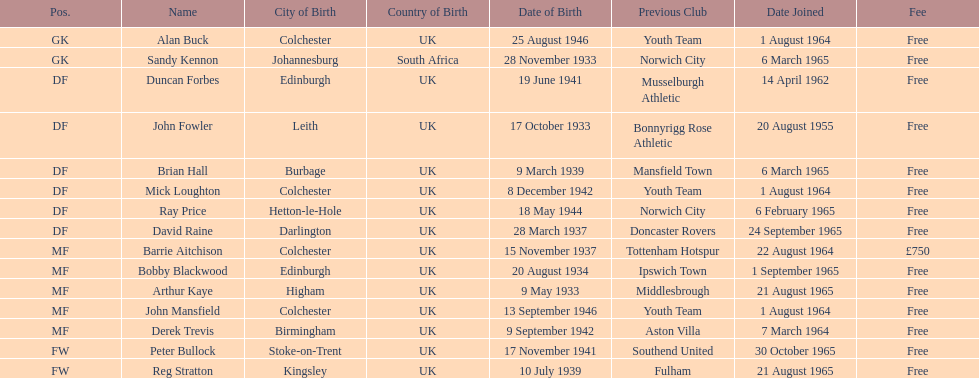Name the player whose fee was not free. Barrie Aitchison. 